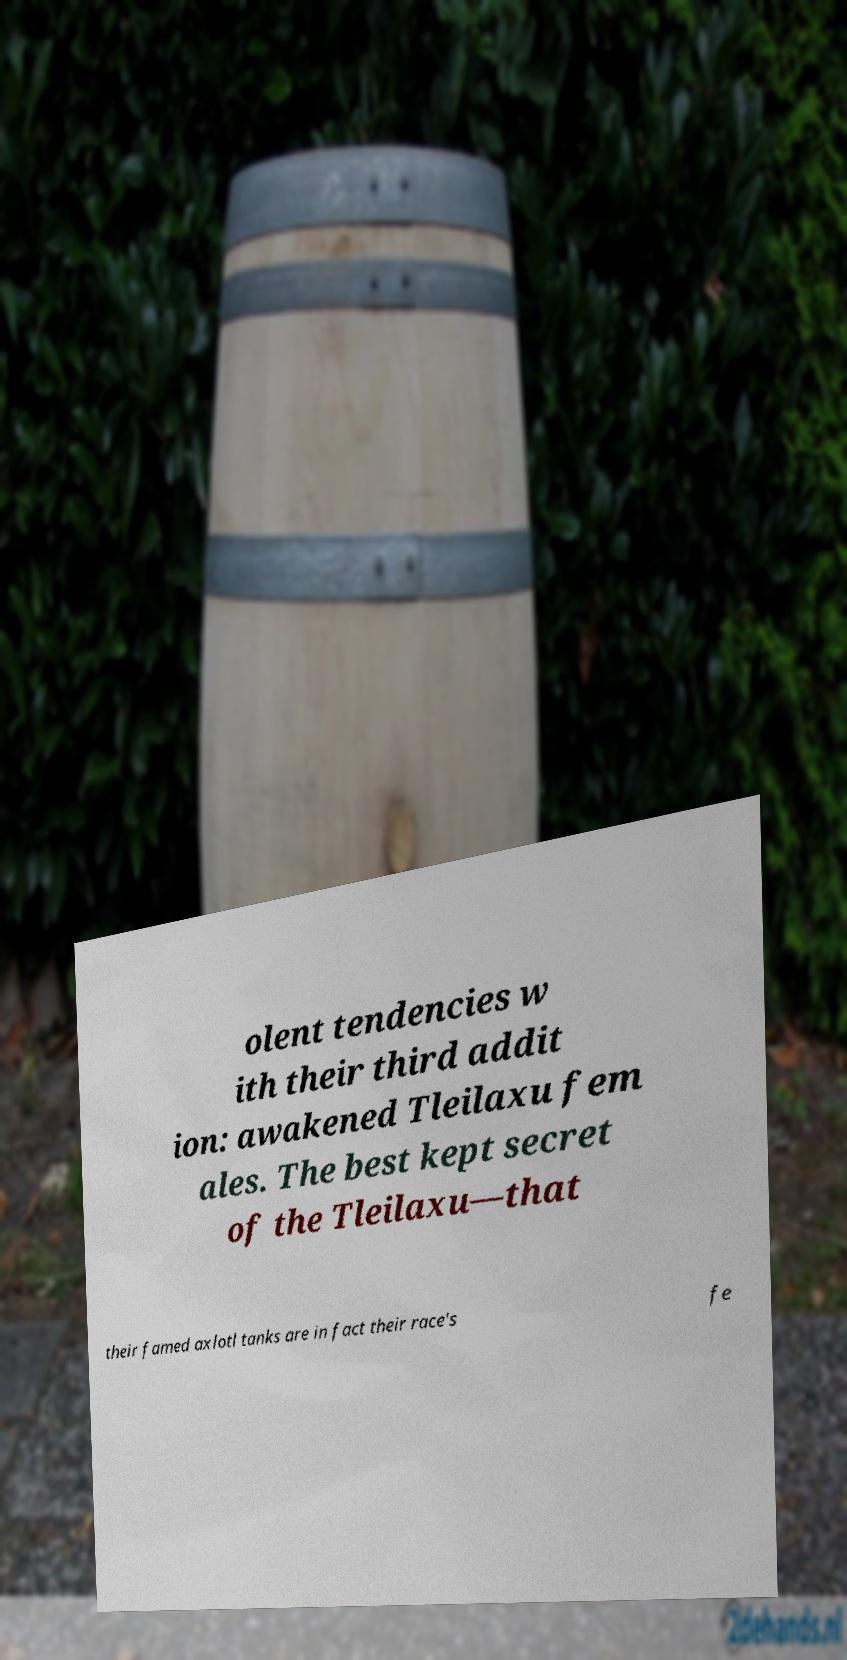Please identify and transcribe the text found in this image. olent tendencies w ith their third addit ion: awakened Tleilaxu fem ales. The best kept secret of the Tleilaxu—that their famed axlotl tanks are in fact their race's fe 